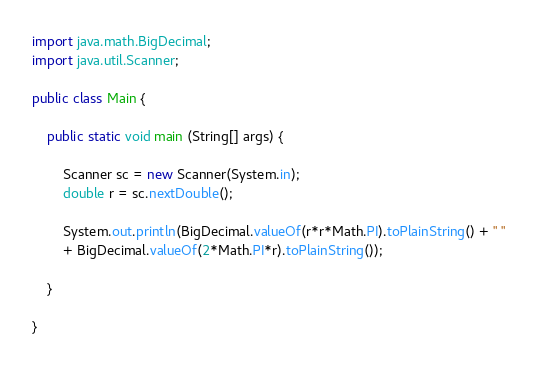<code> <loc_0><loc_0><loc_500><loc_500><_Java_>import java.math.BigDecimal;
import java.util.Scanner;

public class Main {

	public static void main (String[] args) {

		Scanner sc = new Scanner(System.in);
		double r = sc.nextDouble();

		System.out.println(BigDecimal.valueOf(r*r*Math.PI).toPlainString() + " "
		+ BigDecimal.valueOf(2*Math.PI*r).toPlainString());

	}

}

</code> 